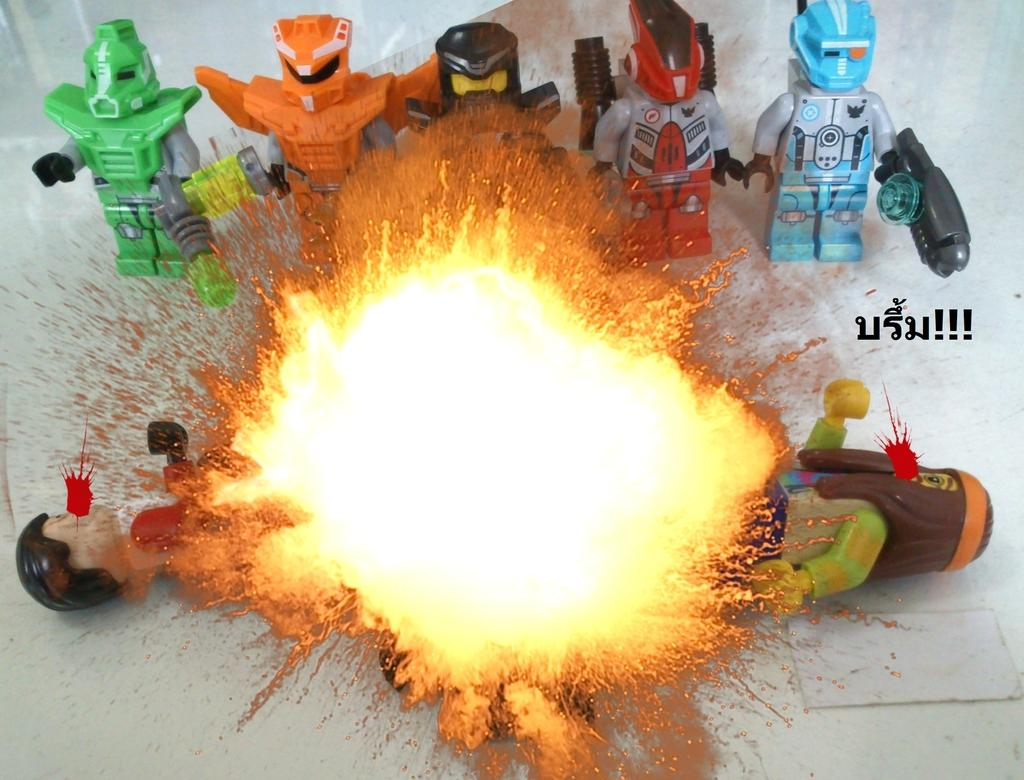What objects can be seen in the image? There are toys in the image. What else is present in the image besides toys? There is fire in the image. What type of hair can be seen on the toys in the image? There is no hair present on the toys in the image. What kind of popcorn is being served with the toys in the image? There is no popcorn present in the image. 